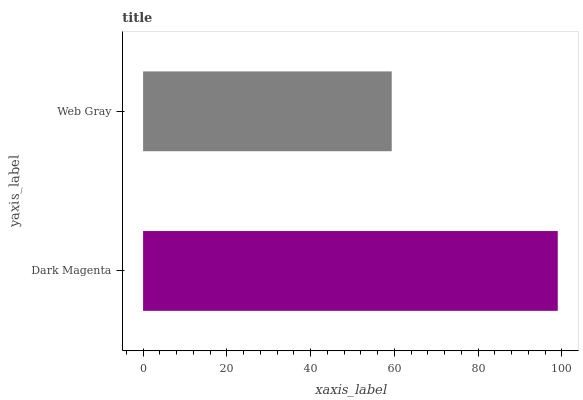Is Web Gray the minimum?
Answer yes or no. Yes. Is Dark Magenta the maximum?
Answer yes or no. Yes. Is Web Gray the maximum?
Answer yes or no. No. Is Dark Magenta greater than Web Gray?
Answer yes or no. Yes. Is Web Gray less than Dark Magenta?
Answer yes or no. Yes. Is Web Gray greater than Dark Magenta?
Answer yes or no. No. Is Dark Magenta less than Web Gray?
Answer yes or no. No. Is Dark Magenta the high median?
Answer yes or no. Yes. Is Web Gray the low median?
Answer yes or no. Yes. Is Web Gray the high median?
Answer yes or no. No. Is Dark Magenta the low median?
Answer yes or no. No. 